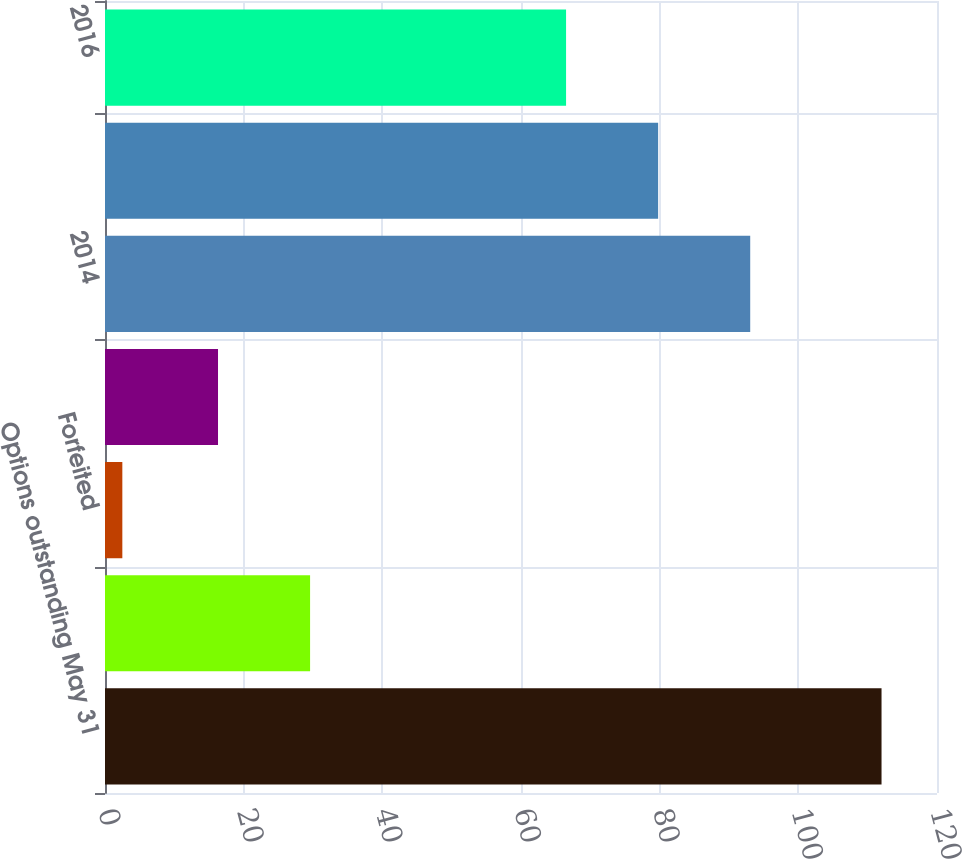<chart> <loc_0><loc_0><loc_500><loc_500><bar_chart><fcel>Options outstanding May 31<fcel>Exercised<fcel>Forfeited<fcel>Granted<fcel>2014<fcel>2015<fcel>2016<nl><fcel>112<fcel>29.58<fcel>2.5<fcel>16.3<fcel>93.06<fcel>79.78<fcel>66.5<nl></chart> 